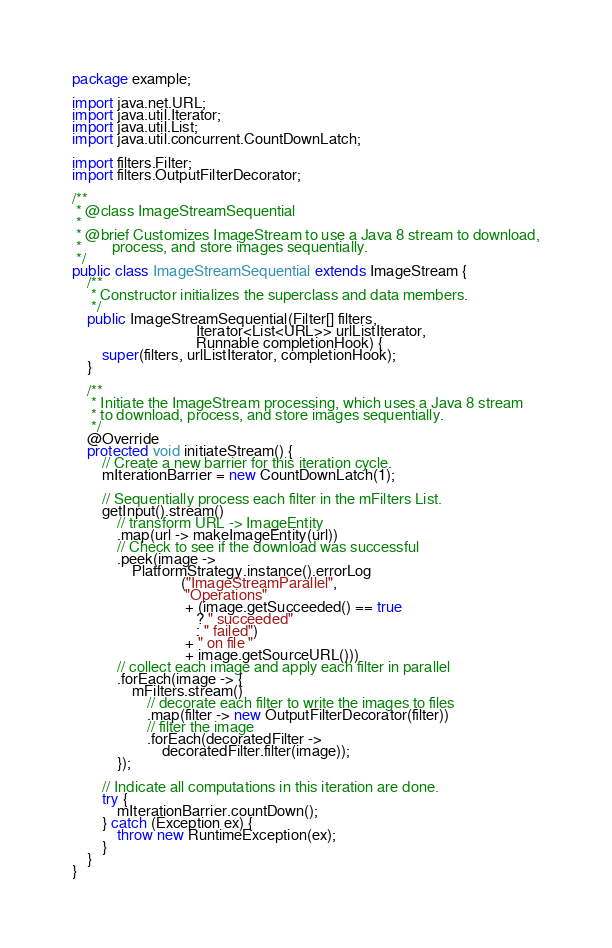<code> <loc_0><loc_0><loc_500><loc_500><_Java_>package example;

import java.net.URL;
import java.util.Iterator;
import java.util.List;
import java.util.concurrent.CountDownLatch;

import filters.Filter;
import filters.OutputFilterDecorator;

/**
 * @class ImageStreamSequential
 *
 * @brief Customizes ImageStream to use a Java 8 stream to download,
 *        process, and store images sequentially.
 */
public class ImageStreamSequential extends ImageStream {
    /**
     * Constructor initializes the superclass and data members.
     */
    public ImageStreamSequential(Filter[] filters,
                                 Iterator<List<URL>> urlListIterator,
                                 Runnable completionHook) {
        super(filters, urlListIterator, completionHook);
    }

    /**
     * Initiate the ImageStream processing, which uses a Java 8 stream
     * to download, process, and store images sequentially.
     */
    @Override
    protected void initiateStream() {
        // Create a new barrier for this iteration cycle.
        mIterationBarrier = new CountDownLatch(1);

        // Sequentially process each filter in the mFilters List.
        getInput().stream()
	    	// transform URL -> ImageEntity
	    	.map(url -> makeImageEntity(url))
	    	// Check to see if the download was successful
	    	.peek(image -> 
	    		PlatformStrategy.instance().errorLog
	                         ("ImageStreamParallel",
	                          "Operations"
	                          + (image.getSucceeded() == true 
	                             ? " succeeded" 
	                             : " failed")
	                          + " on file " 
	                          + image.getSourceURL()))
	        // collect each image and apply each filter in parallel
	    	.forEach(image -> {
	    		mFilters.stream()
	    			// decorate each filter to write the images to files
	    			.map(filter -> new OutputFilterDecorator(filter))
	    			// filter the image
	    			.forEach(decoratedFilter -> 
	    				decoratedFilter.filter(image));
	    	});

        // Indicate all computations in this iteration are done.
        try {
            mIterationBarrier.countDown();
        } catch (Exception ex) {
            throw new RuntimeException(ex);
        } 
    }
}
</code> 